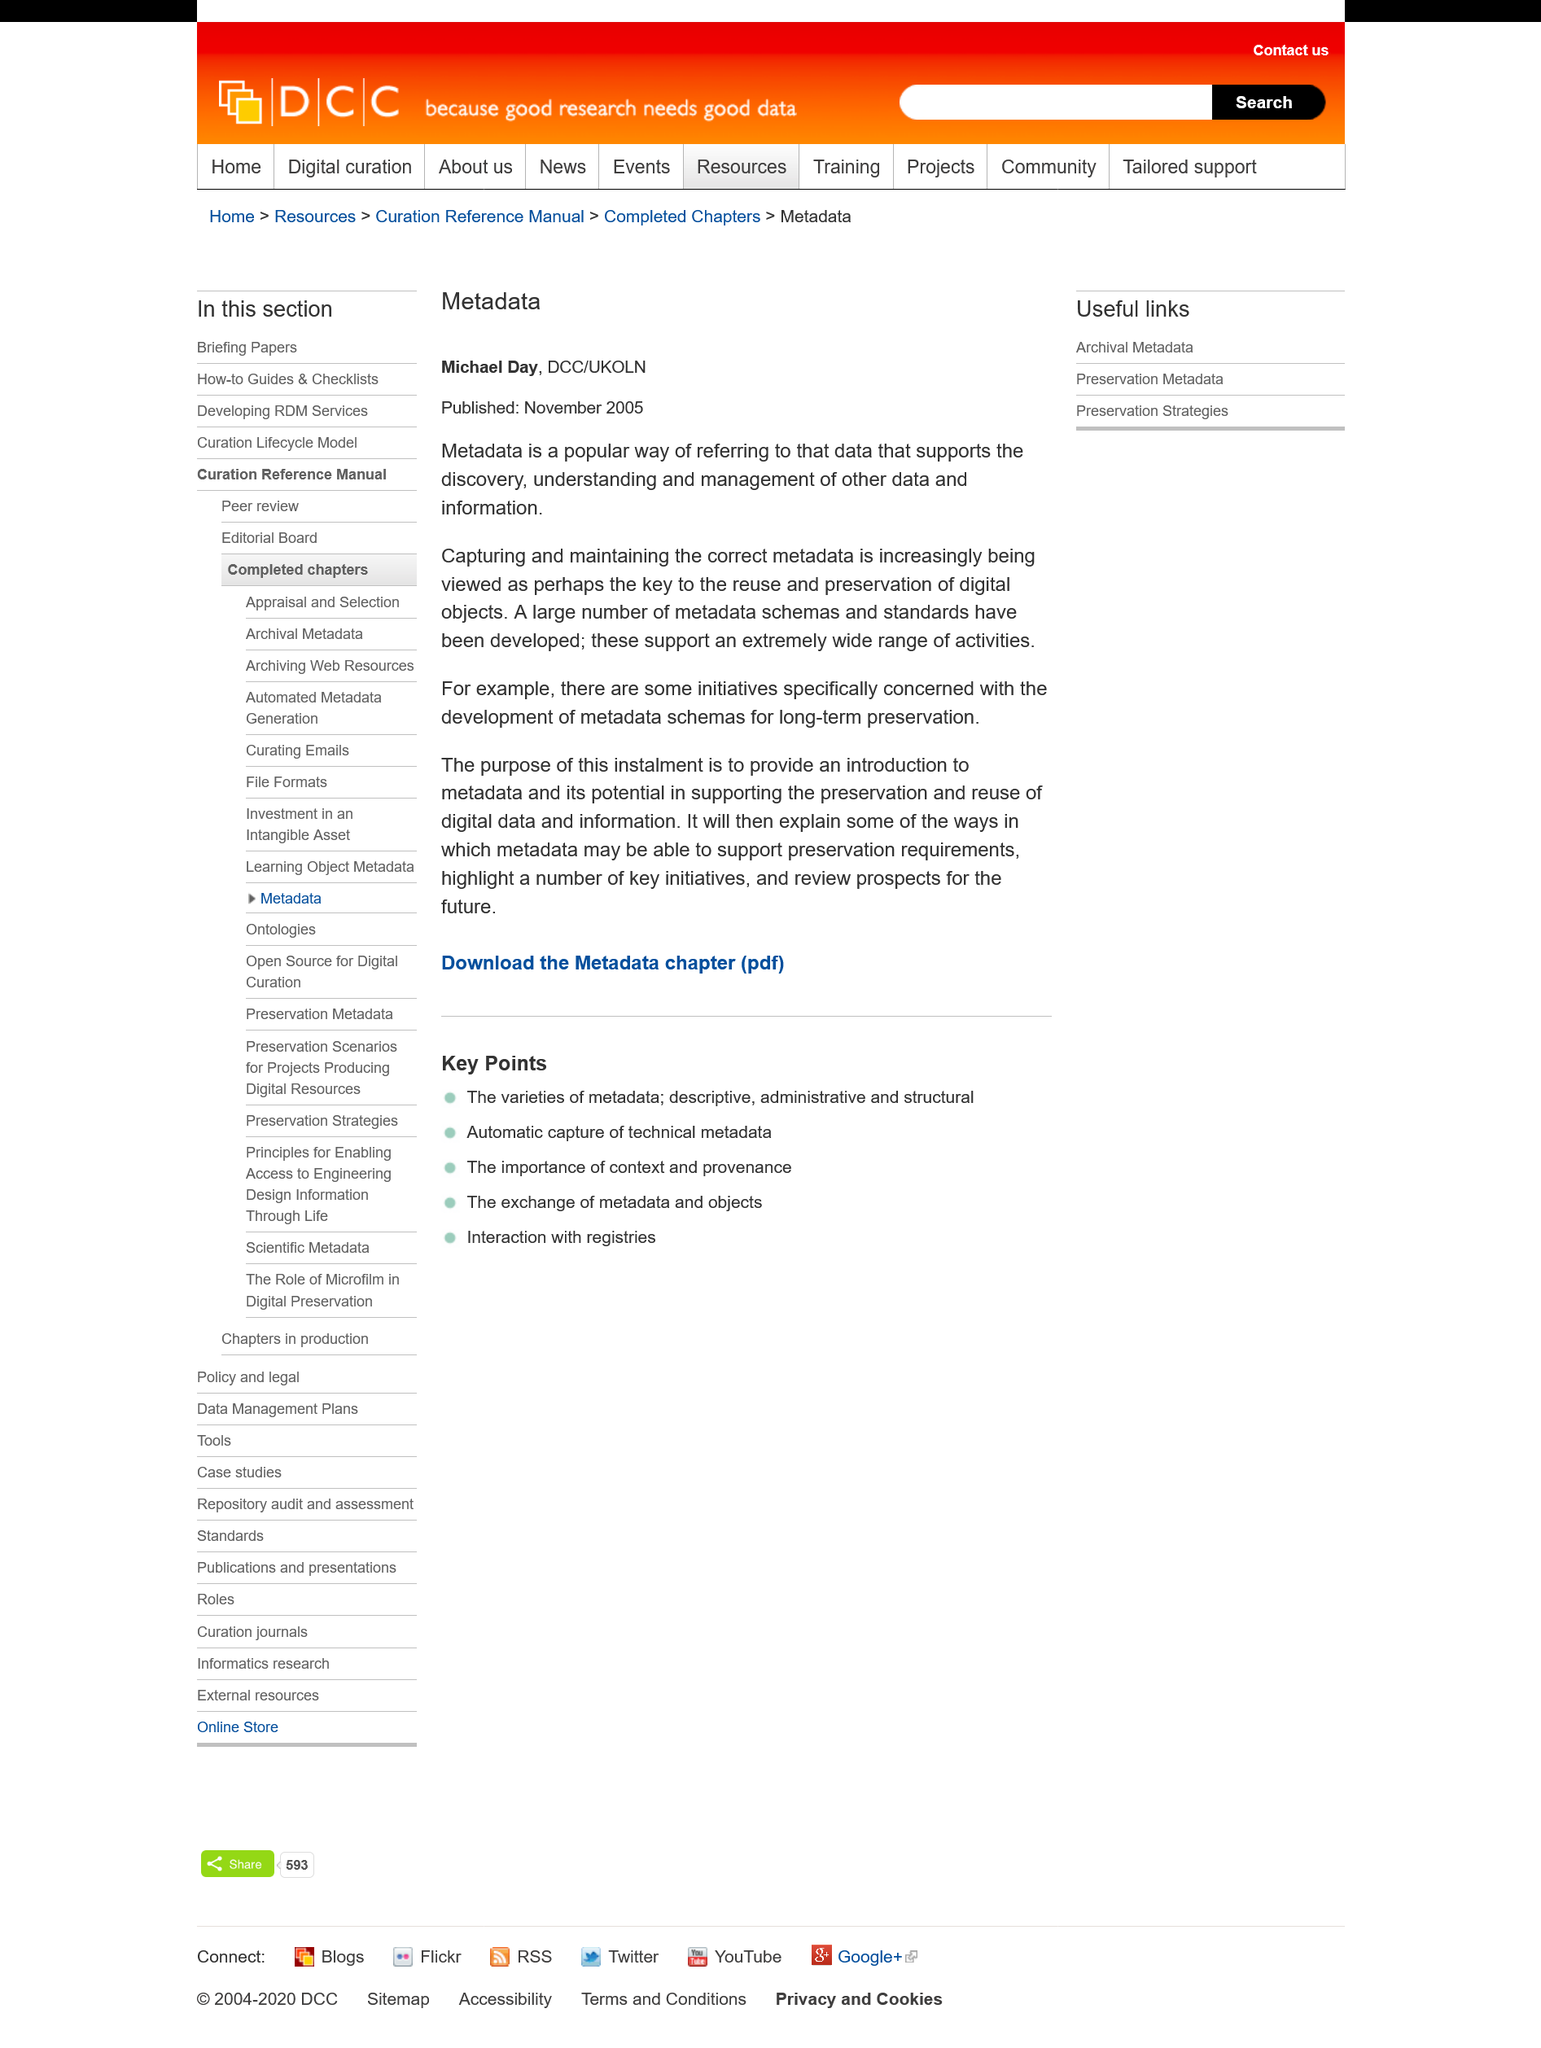Indicate a few pertinent items in this graphic. Michael Day is a member of DCC/UKOLN, an organization that focuses on supporting and promoting the use of digital technologies in education and research. The article on 'Metadata' was written by Michael Day. The article on 'Metadata' was published in November 2005. 